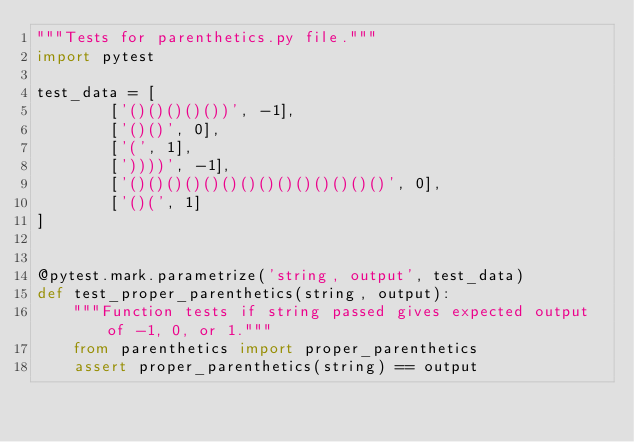Convert code to text. <code><loc_0><loc_0><loc_500><loc_500><_Python_>"""Tests for parenthetics.py file."""
import pytest

test_data = [
        ['()()()()())', -1],
        ['()()', 0],
        ['(', 1],
        ['))))', -1],
        ['()()()()()()()()()()()()()()', 0],
        ['()(', 1]
]


@pytest.mark.parametrize('string, output', test_data)
def test_proper_parenthetics(string, output):
    """Function tests if string passed gives expected output of -1, 0, or 1."""
    from parenthetics import proper_parenthetics
    assert proper_parenthetics(string) == output
</code> 